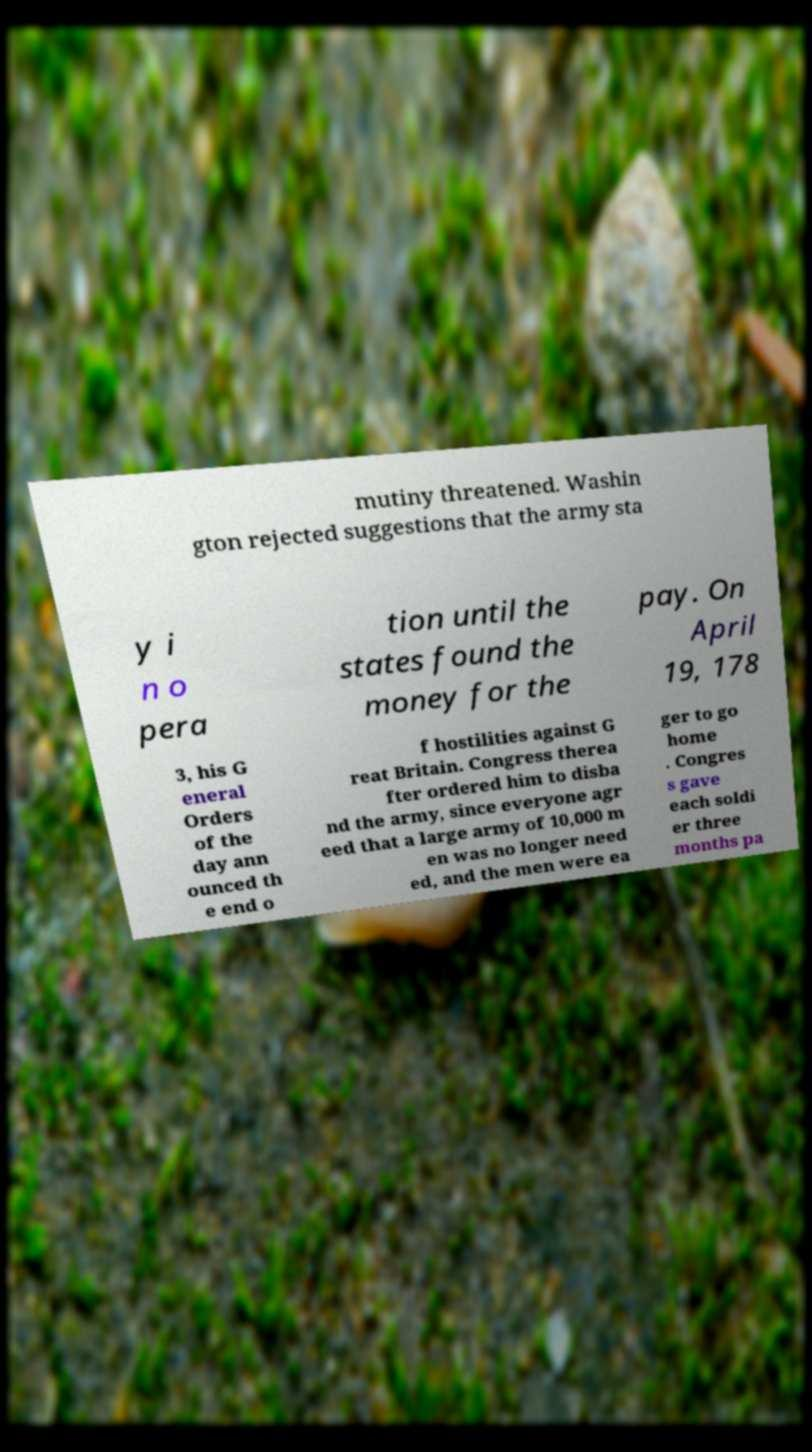I need the written content from this picture converted into text. Can you do that? mutiny threatened. Washin gton rejected suggestions that the army sta y i n o pera tion until the states found the money for the pay. On April 19, 178 3, his G eneral Orders of the day ann ounced th e end o f hostilities against G reat Britain. Congress therea fter ordered him to disba nd the army, since everyone agr eed that a large army of 10,000 m en was no longer need ed, and the men were ea ger to go home . Congres s gave each soldi er three months pa 